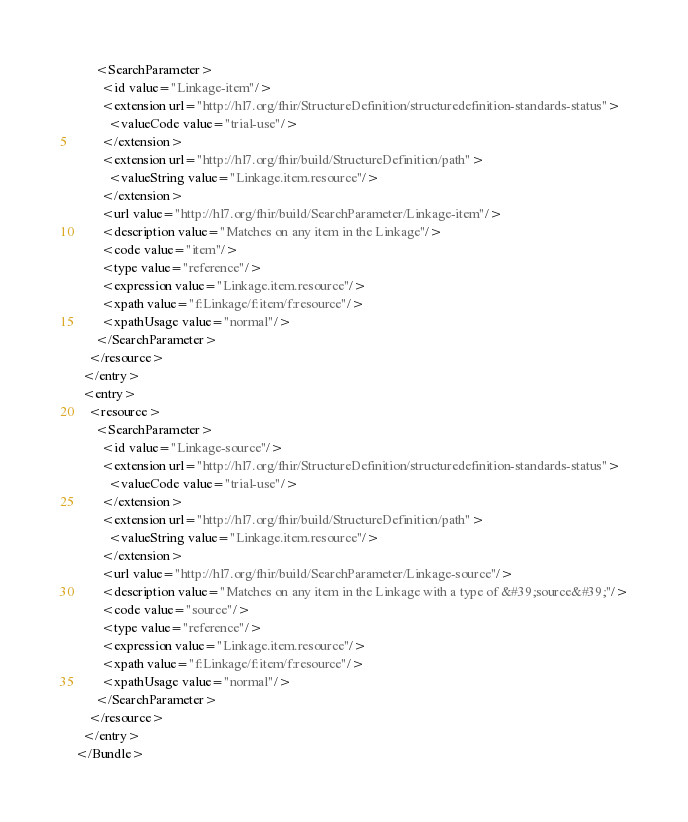Convert code to text. <code><loc_0><loc_0><loc_500><loc_500><_XML_>      <SearchParameter>
        <id value="Linkage-item"/>
        <extension url="http://hl7.org/fhir/StructureDefinition/structuredefinition-standards-status">
          <valueCode value="trial-use"/>
        </extension>
        <extension url="http://hl7.org/fhir/build/StructureDefinition/path">
          <valueString value="Linkage.item.resource"/>
        </extension>
        <url value="http://hl7.org/fhir/build/SearchParameter/Linkage-item"/>
        <description value="Matches on any item in the Linkage"/>
        <code value="item"/>
        <type value="reference"/>
        <expression value="Linkage.item.resource"/>
        <xpath value="f:Linkage/f:item/f:resource"/>
        <xpathUsage value="normal"/>
      </SearchParameter>
    </resource>
  </entry>
  <entry>
    <resource>
      <SearchParameter>
        <id value="Linkage-source"/>
        <extension url="http://hl7.org/fhir/StructureDefinition/structuredefinition-standards-status">
          <valueCode value="trial-use"/>
        </extension>
        <extension url="http://hl7.org/fhir/build/StructureDefinition/path">
          <valueString value="Linkage.item.resource"/>
        </extension>
        <url value="http://hl7.org/fhir/build/SearchParameter/Linkage-source"/>
        <description value="Matches on any item in the Linkage with a type of &#39;source&#39;"/>
        <code value="source"/>
        <type value="reference"/>
        <expression value="Linkage.item.resource"/>
        <xpath value="f:Linkage/f:item/f:resource"/>
        <xpathUsage value="normal"/>
      </SearchParameter>
    </resource>
  </entry>
</Bundle></code> 